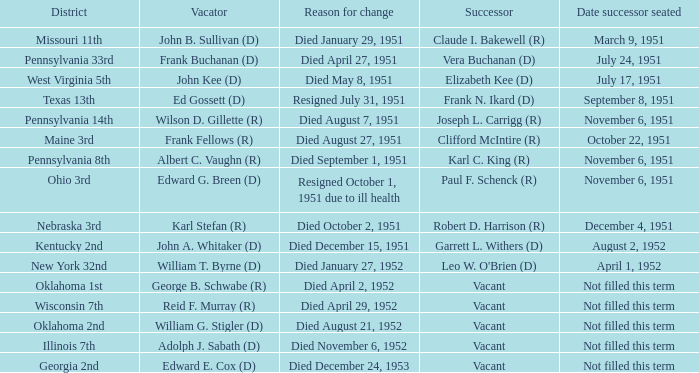Who was the successor for the Kentucky 2nd district? Garrett L. Withers (D). 